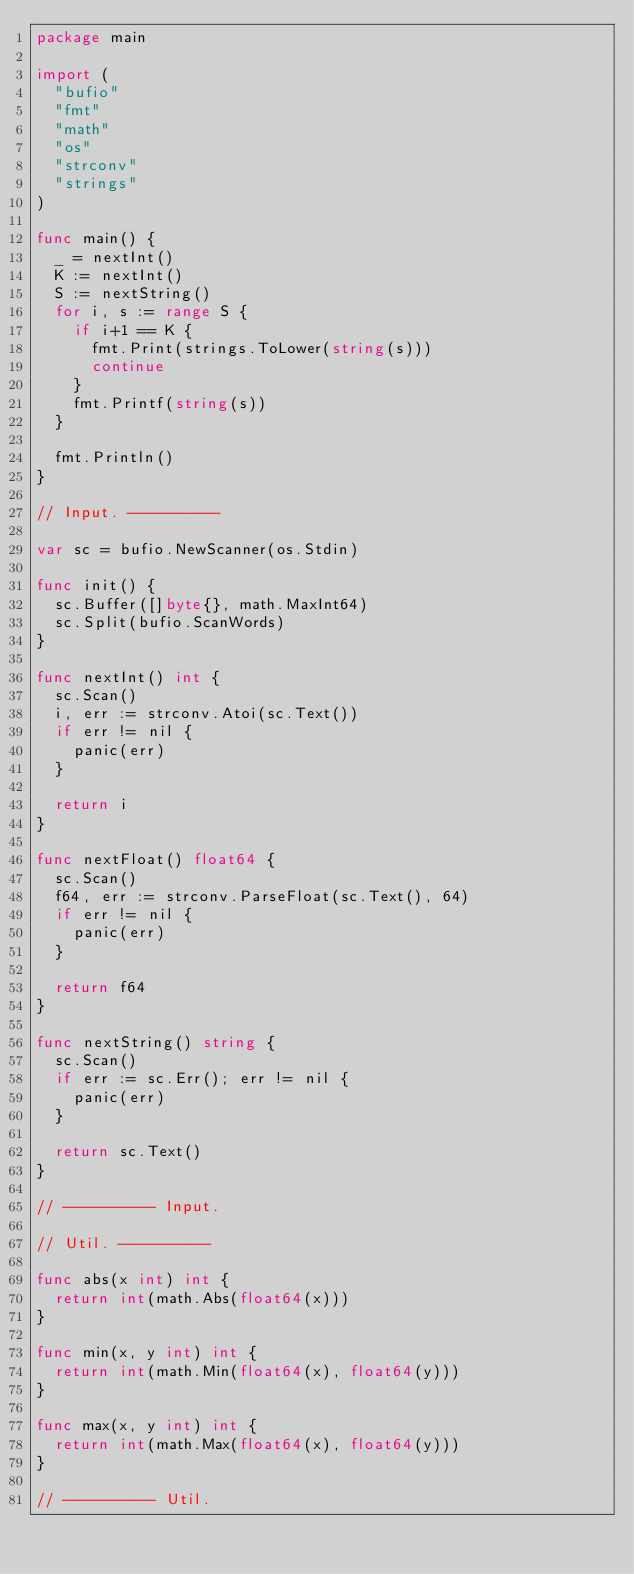<code> <loc_0><loc_0><loc_500><loc_500><_Go_>package main

import (
	"bufio"
	"fmt"
	"math"
	"os"
	"strconv"
	"strings"
)

func main() {
	_ = nextInt()
	K := nextInt()
	S := nextString()
	for i, s := range S {
		if i+1 == K {
			fmt.Print(strings.ToLower(string(s)))
			continue
		}
		fmt.Printf(string(s))
	}

	fmt.Println()
}

// Input. ----------

var sc = bufio.NewScanner(os.Stdin)

func init() {
	sc.Buffer([]byte{}, math.MaxInt64)
	sc.Split(bufio.ScanWords)
}

func nextInt() int {
	sc.Scan()
	i, err := strconv.Atoi(sc.Text())
	if err != nil {
		panic(err)
	}

	return i
}

func nextFloat() float64 {
	sc.Scan()
	f64, err := strconv.ParseFloat(sc.Text(), 64)
	if err != nil {
		panic(err)
	}

	return f64
}

func nextString() string {
	sc.Scan()
	if err := sc.Err(); err != nil {
		panic(err)
	}

	return sc.Text()
}

// ---------- Input.

// Util. ----------

func abs(x int) int {
	return int(math.Abs(float64(x)))
}

func min(x, y int) int {
	return int(math.Min(float64(x), float64(y)))
}

func max(x, y int) int {
	return int(math.Max(float64(x), float64(y)))
}

// ---------- Util.
</code> 